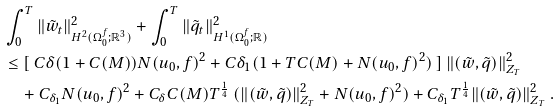Convert formula to latex. <formula><loc_0><loc_0><loc_500><loc_500>& \int _ { 0 } ^ { T } \| { \tilde { w } _ { t } } \| ^ { 2 } _ { H ^ { 2 } ( \Omega _ { 0 } ^ { f } ; { \mathbb { R } } ^ { 3 } ) } + \int _ { 0 } ^ { T } \| { \tilde { q } _ { t } } \| ^ { 2 } _ { H ^ { 1 } ( \Omega _ { 0 } ^ { f } ; { \mathbb { R } } ) } \\ & \leq [ \ C \delta ( 1 + C ( M ) ) N ( u _ { 0 } , f ) ^ { 2 } + C { \delta _ { 1 } } ( 1 + T C ( M ) + N ( u _ { 0 } , f ) ^ { 2 } ) \ ] \ \| ( \tilde { w } , \tilde { q } ) \| ^ { 2 } _ { Z _ { T } } \\ & \quad + C _ { \delta _ { 1 } } N ( u _ { 0 } , f ) ^ { 2 } + C _ { \delta } C ( M ) T ^ { \frac { 1 } { 4 } } \ ( \| ( \tilde { w } , \tilde { q } ) \| ^ { 2 } _ { Z _ { T } } + N ( u _ { 0 } , f ) ^ { 2 } ) + C _ { \delta _ { 1 } } T ^ { \frac { 1 } { 4 } } \| ( \tilde { w } , \tilde { q } ) \| ^ { 2 } _ { Z _ { T } } \ .</formula> 